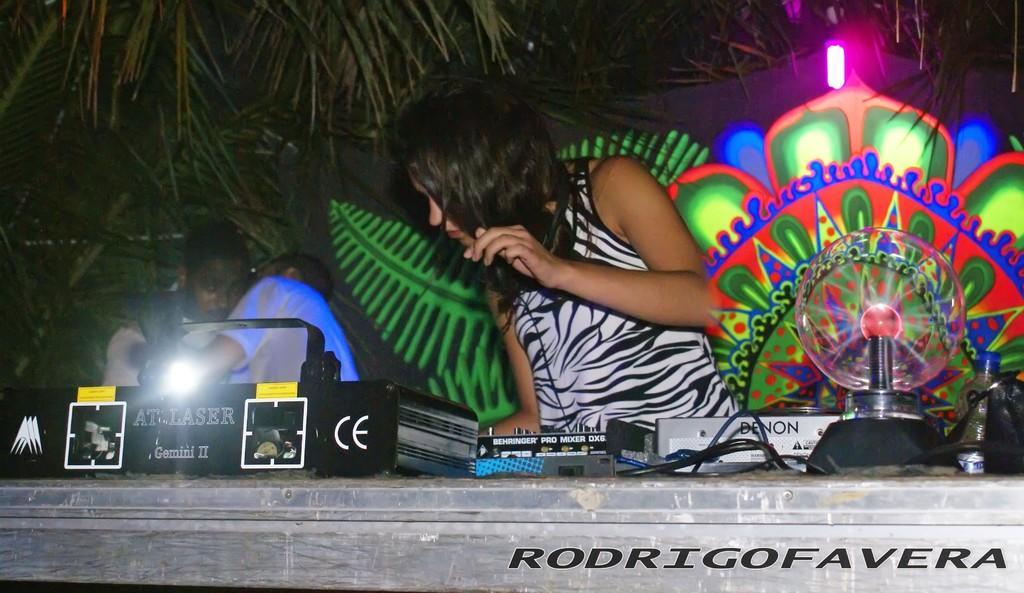In one or two sentences, can you explain what this image depicts? In the picture I can see a person wearing a white color dress is carrying headphones and here we can see some objects are placed on the table and we can see some text on it. The background of the image is dark where we can see lights, some decorative objects, two persons standing here and we can see trees. 